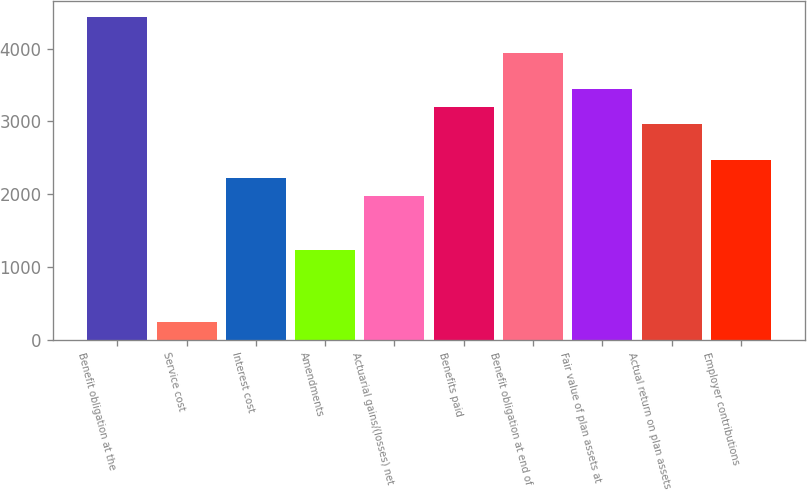<chart> <loc_0><loc_0><loc_500><loc_500><bar_chart><fcel>Benefit obligation at the<fcel>Service cost<fcel>Interest cost<fcel>Amendments<fcel>Actuarial gains/(losses) net<fcel>Benefits paid<fcel>Benefit obligation at end of<fcel>Fair value of plan assets at<fcel>Actual return on plan assets<fcel>Employer contributions<nl><fcel>4435.4<fcel>248.3<fcel>2218.7<fcel>1233.5<fcel>1972.4<fcel>3203.9<fcel>3942.8<fcel>3450.2<fcel>2957.6<fcel>2465<nl></chart> 